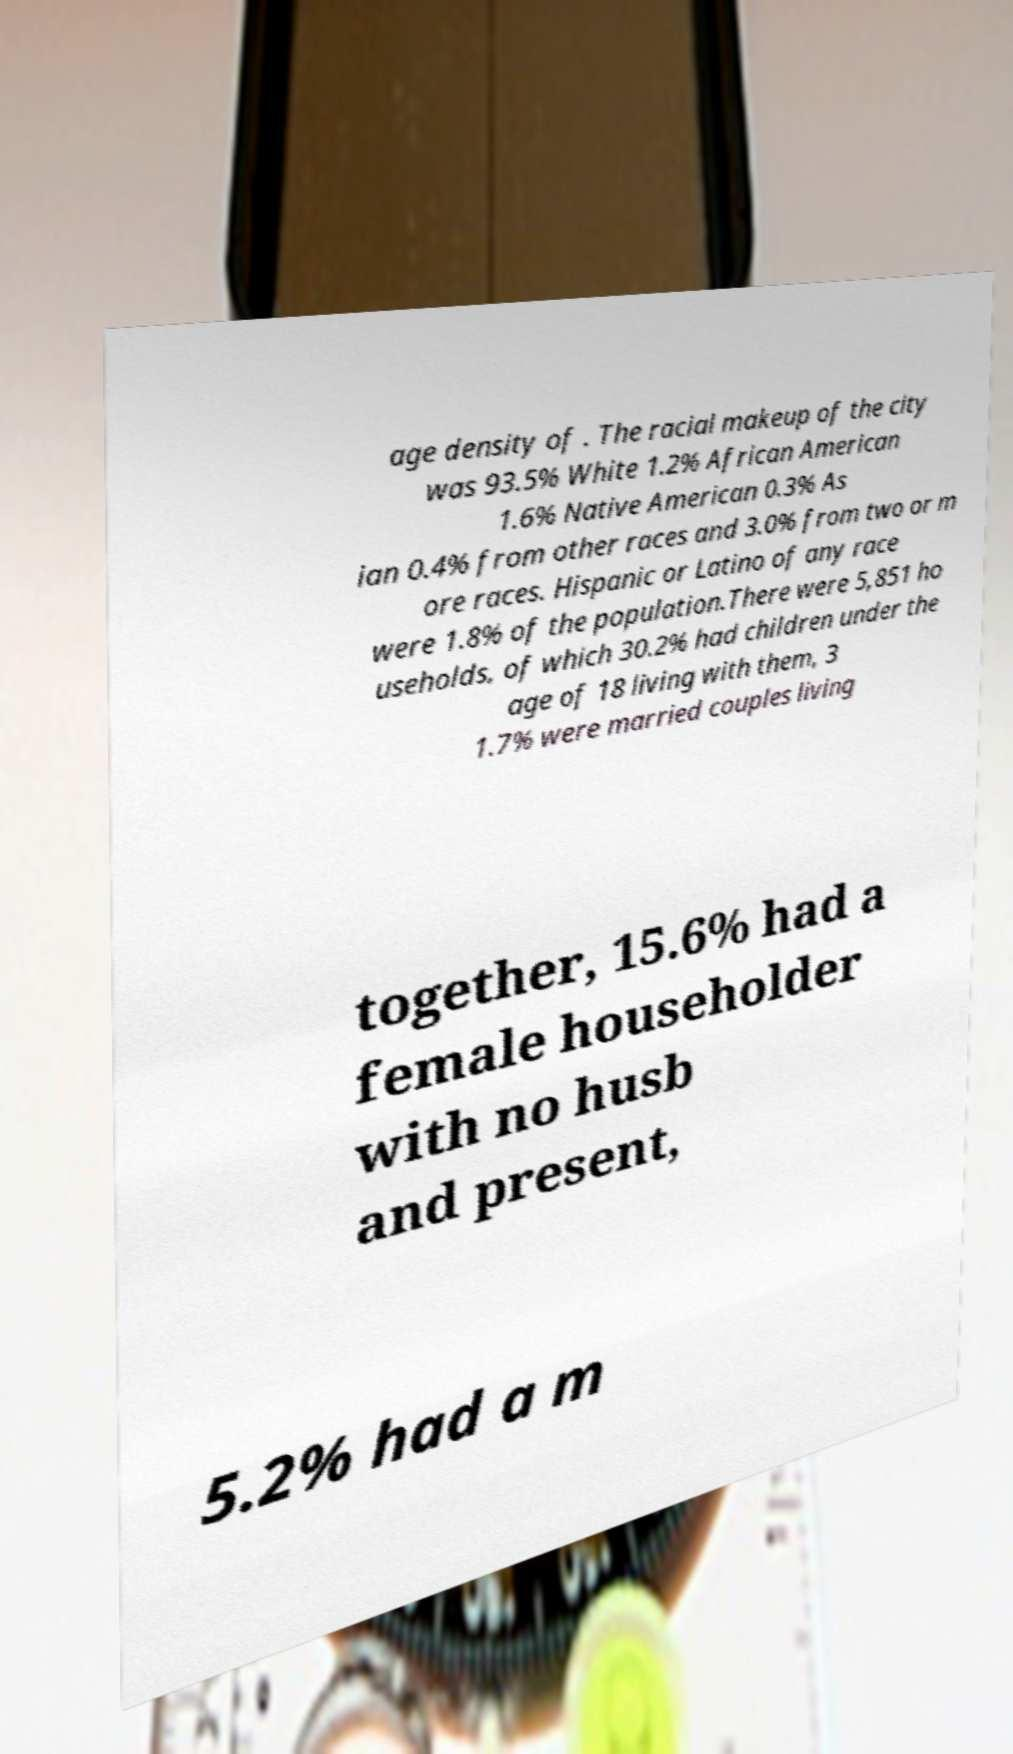What messages or text are displayed in this image? I need them in a readable, typed format. age density of . The racial makeup of the city was 93.5% White 1.2% African American 1.6% Native American 0.3% As ian 0.4% from other races and 3.0% from two or m ore races. Hispanic or Latino of any race were 1.8% of the population.There were 5,851 ho useholds, of which 30.2% had children under the age of 18 living with them, 3 1.7% were married couples living together, 15.6% had a female householder with no husb and present, 5.2% had a m 